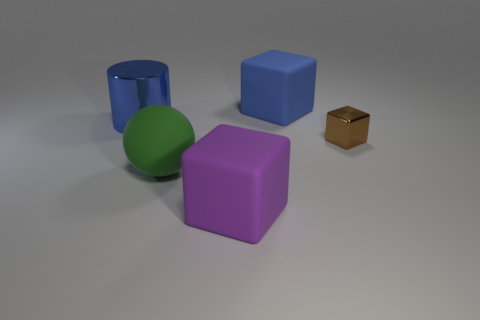Subtract all blue spheres. Subtract all brown cylinders. How many spheres are left? 1 Add 4 metal things. How many objects exist? 9 Subtract all balls. How many objects are left? 4 Add 1 rubber objects. How many rubber objects exist? 4 Subtract 0 cyan cylinders. How many objects are left? 5 Subtract all large cyan metal objects. Subtract all tiny metal cubes. How many objects are left? 4 Add 1 large blue rubber objects. How many large blue rubber objects are left? 2 